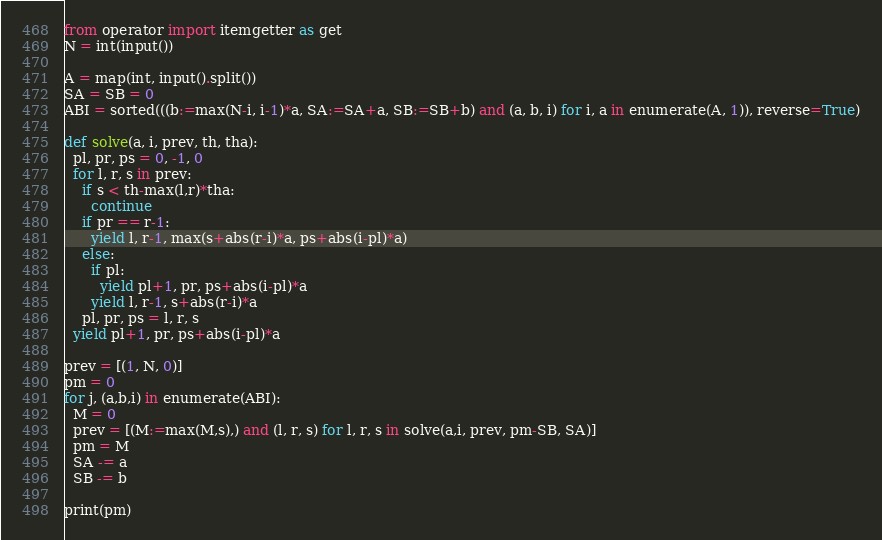Convert code to text. <code><loc_0><loc_0><loc_500><loc_500><_Python_>from operator import itemgetter as get
N = int(input())

A = map(int, input().split())
SA = SB = 0
ABI = sorted(((b:=max(N-i, i-1)*a, SA:=SA+a, SB:=SB+b) and (a, b, i) for i, a in enumerate(A, 1)), reverse=True)

def solve(a, i, prev, th, tha):
  pl, pr, ps = 0, -1, 0
  for l, r, s in prev:
    if s < th-max(l,r)*tha:
      continue
    if pr == r-1:
      yield l, r-1, max(s+abs(r-i)*a, ps+abs(i-pl)*a)
    else:
      if pl:
        yield pl+1, pr, ps+abs(i-pl)*a
      yield l, r-1, s+abs(r-i)*a
    pl, pr, ps = l, r, s
  yield pl+1, pr, ps+abs(i-pl)*a

prev = [(1, N, 0)]
pm = 0
for j, (a,b,i) in enumerate(ABI):
  M = 0
  prev = [(M:=max(M,s),) and (l, r, s) for l, r, s in solve(a,i, prev, pm-SB, SA)]
  pm = M
  SA -= a
  SB -= b

print(pm)
</code> 